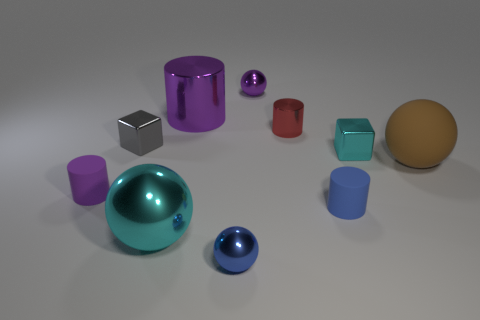Does the gray thing have the same shape as the large matte object that is right of the blue metallic sphere?
Your answer should be very brief. No. Are there fewer small blue metallic balls behind the tiny gray metal cube than cyan objects behind the brown matte object?
Your answer should be very brief. Yes. There is another tiny object that is the same shape as the gray thing; what is it made of?
Ensure brevity in your answer.  Metal. Is there anything else that has the same material as the tiny blue ball?
Make the answer very short. Yes. Does the big rubber sphere have the same color as the small metal cylinder?
Your response must be concise. No. What is the shape of the purple object that is the same material as the brown object?
Keep it short and to the point. Cylinder. What number of small matte objects are the same shape as the red metallic object?
Make the answer very short. 2. There is a purple thing that is in front of the big ball that is behind the small purple rubber cylinder; what is its shape?
Provide a succinct answer. Cylinder. Is the size of the cyan object that is to the right of the blue shiny sphere the same as the gray object?
Give a very brief answer. Yes. There is a metallic thing that is both in front of the gray cube and behind the big cyan shiny thing; what size is it?
Keep it short and to the point. Small. 